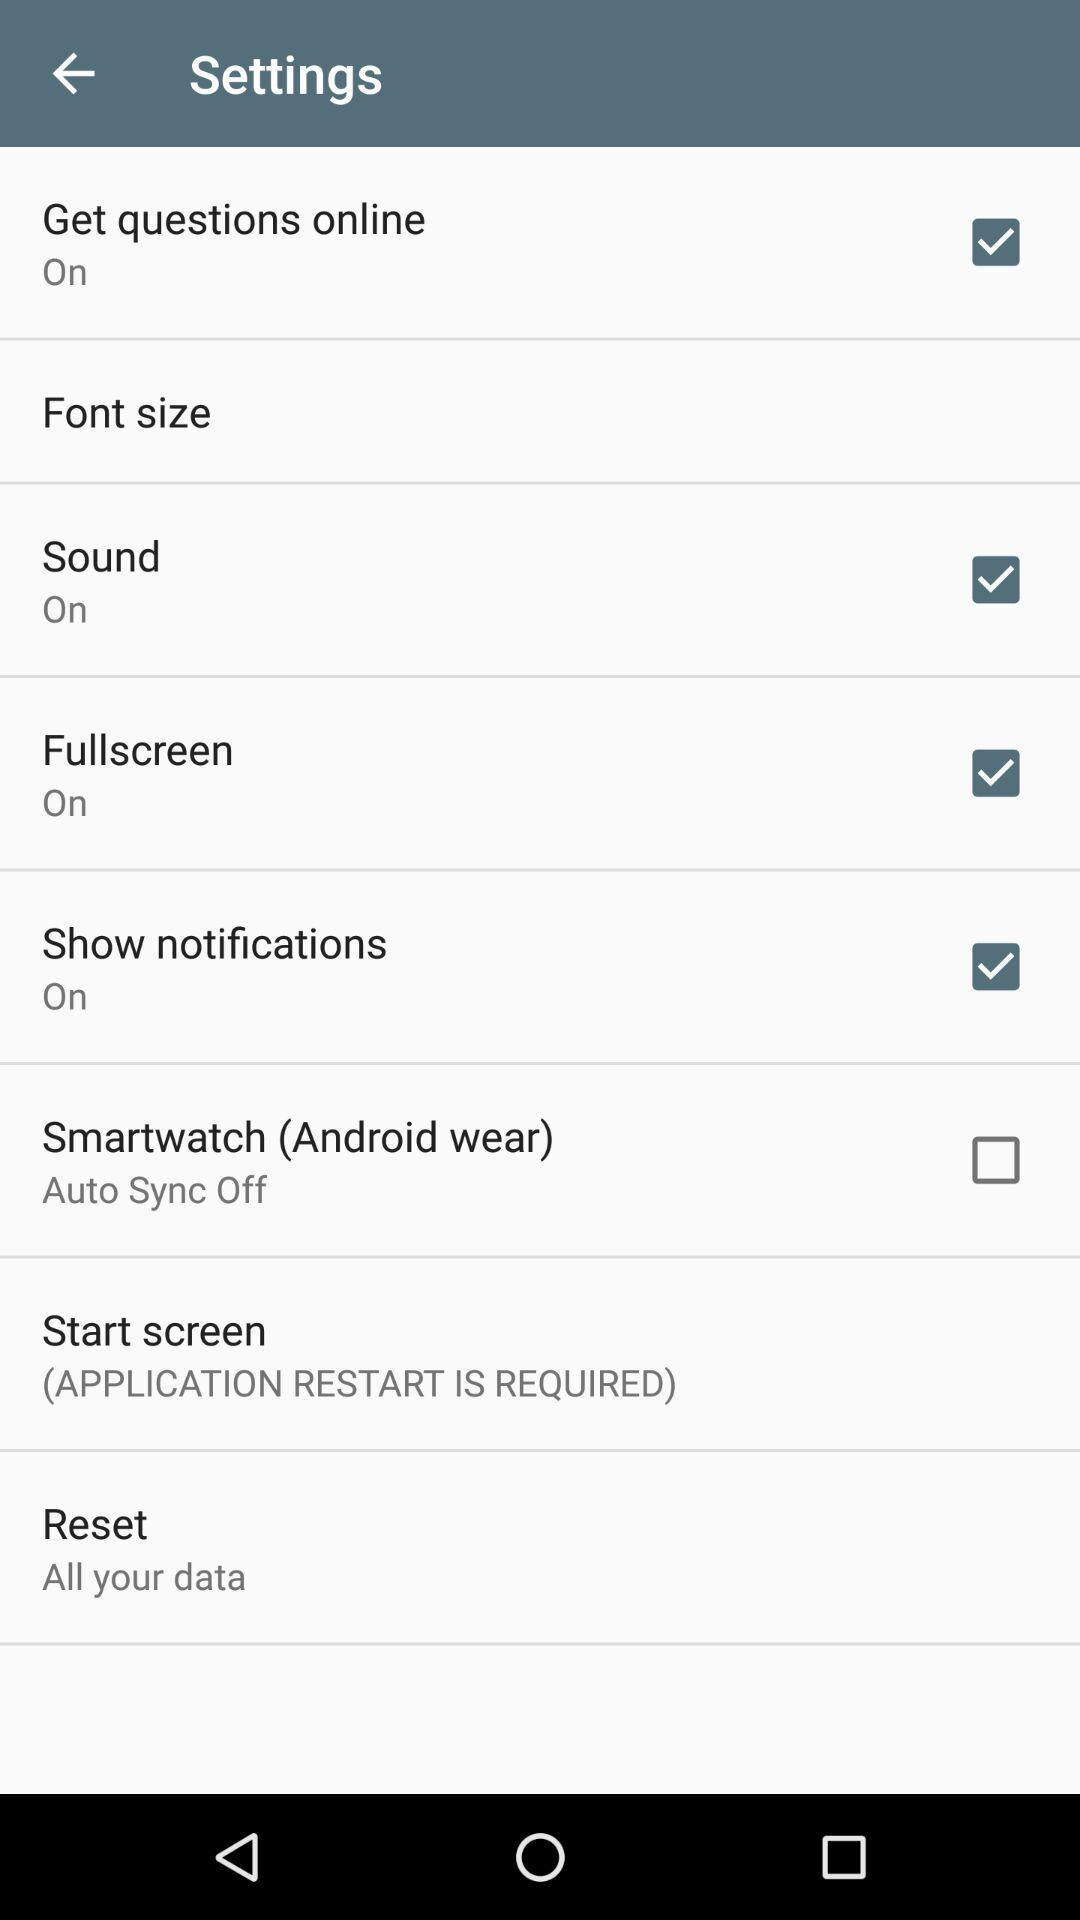What is the status of "Sound"? The status of "Sound" is "on". 